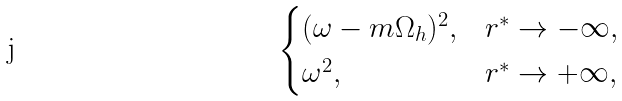<formula> <loc_0><loc_0><loc_500><loc_500>\begin{cases} ( \omega - m \Omega _ { h } ) ^ { 2 } , & r ^ { * } \rightarrow - \infty , \\ \omega ^ { 2 } , & r ^ { * } \rightarrow + \infty , \end{cases}</formula> 